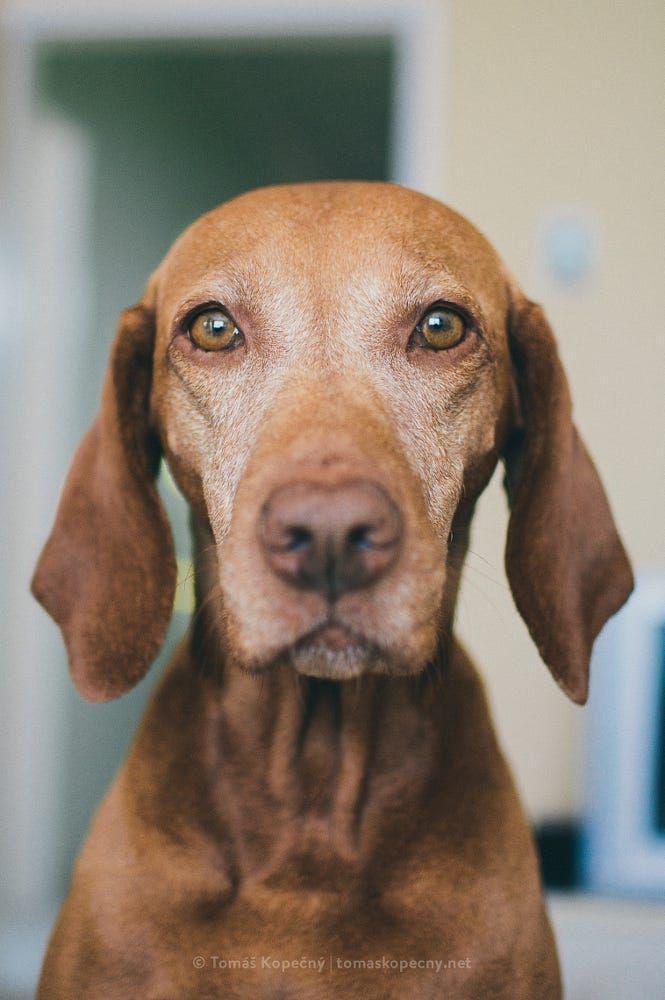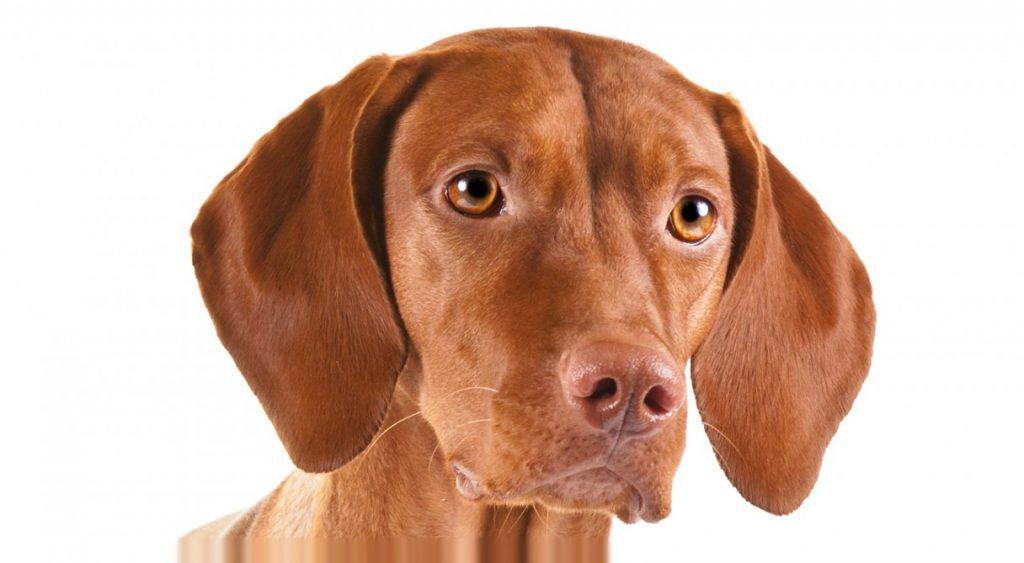The first image is the image on the left, the second image is the image on the right. For the images displayed, is the sentence "Each image contains one red-orange dog, which has its face turned forward." factually correct? Answer yes or no. Yes. The first image is the image on the left, the second image is the image on the right. Considering the images on both sides, is "The dog in the image on the left is sitting on a wooden surface." valid? Answer yes or no. No. 